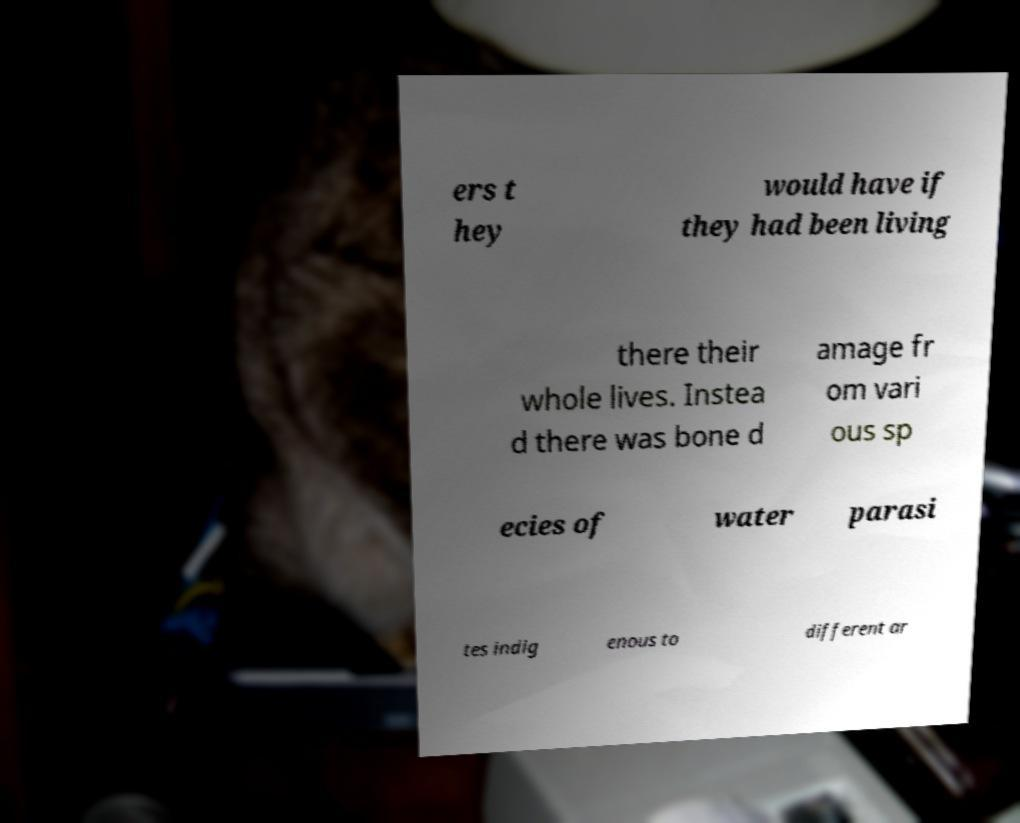What messages or text are displayed in this image? I need them in a readable, typed format. ers t hey would have if they had been living there their whole lives. Instea d there was bone d amage fr om vari ous sp ecies of water parasi tes indig enous to different ar 